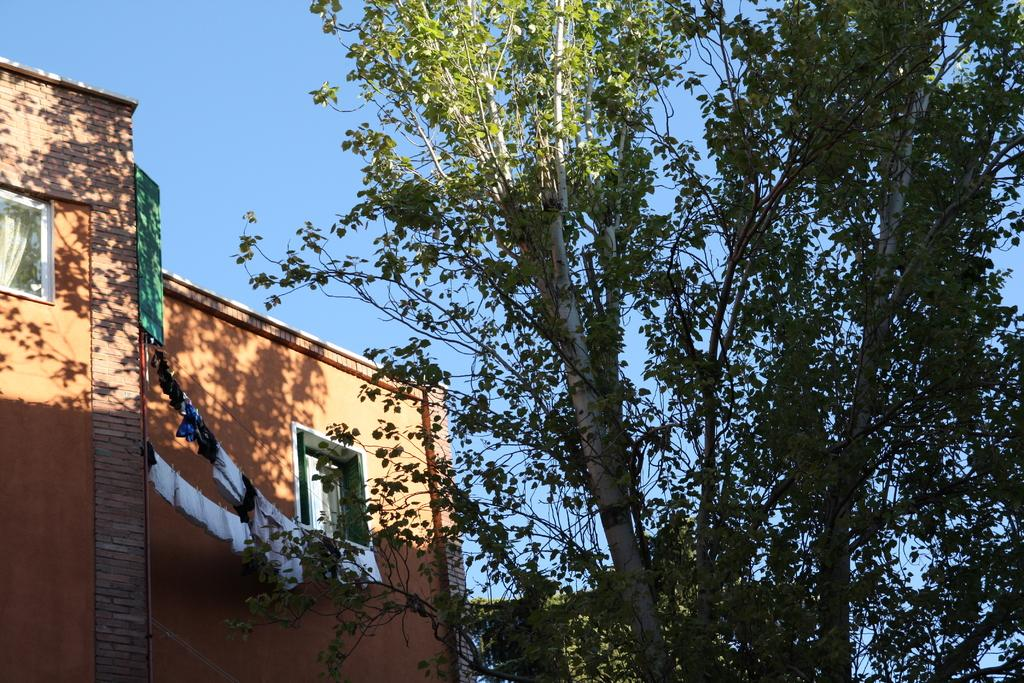What type of structure is visible in the image? There is a building with windows in the image. What can be seen hanging outside the building? Clothes are hanged on ropes in the image. What type of natural element is present in the image? There is a tree in the image. What is visible in the background of the image? The sky is visible in the image. What type of stick can be seen in the image? There is no stick present in the image. How many fingers are visible in the image? There is no reference to fingers in the image. 